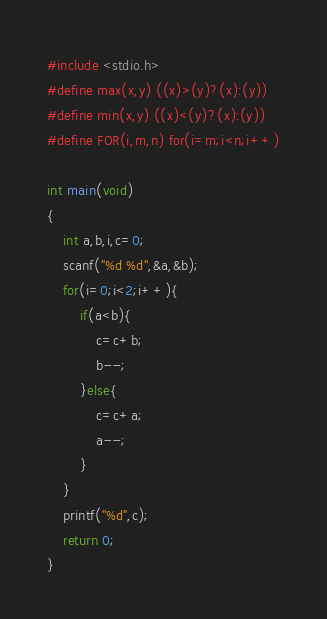<code> <loc_0><loc_0><loc_500><loc_500><_C_>#include <stdio.h>
#define max(x,y) ((x)>(y)?(x):(y))
#define min(x,y) ((x)<(y)?(x):(y))
#define FOR(i,m,n) for(i=m;i<n;i++)

int main(void)
{
	int a,b,i,c=0;
	scanf("%d %d",&a,&b);
	for(i=0;i<2;i++){
		if(a<b){
			c=c+b;
			b--;
		}else{
			c=c+a;
			a--;
		}
	}
	printf("%d",c);
	return 0;
}</code> 